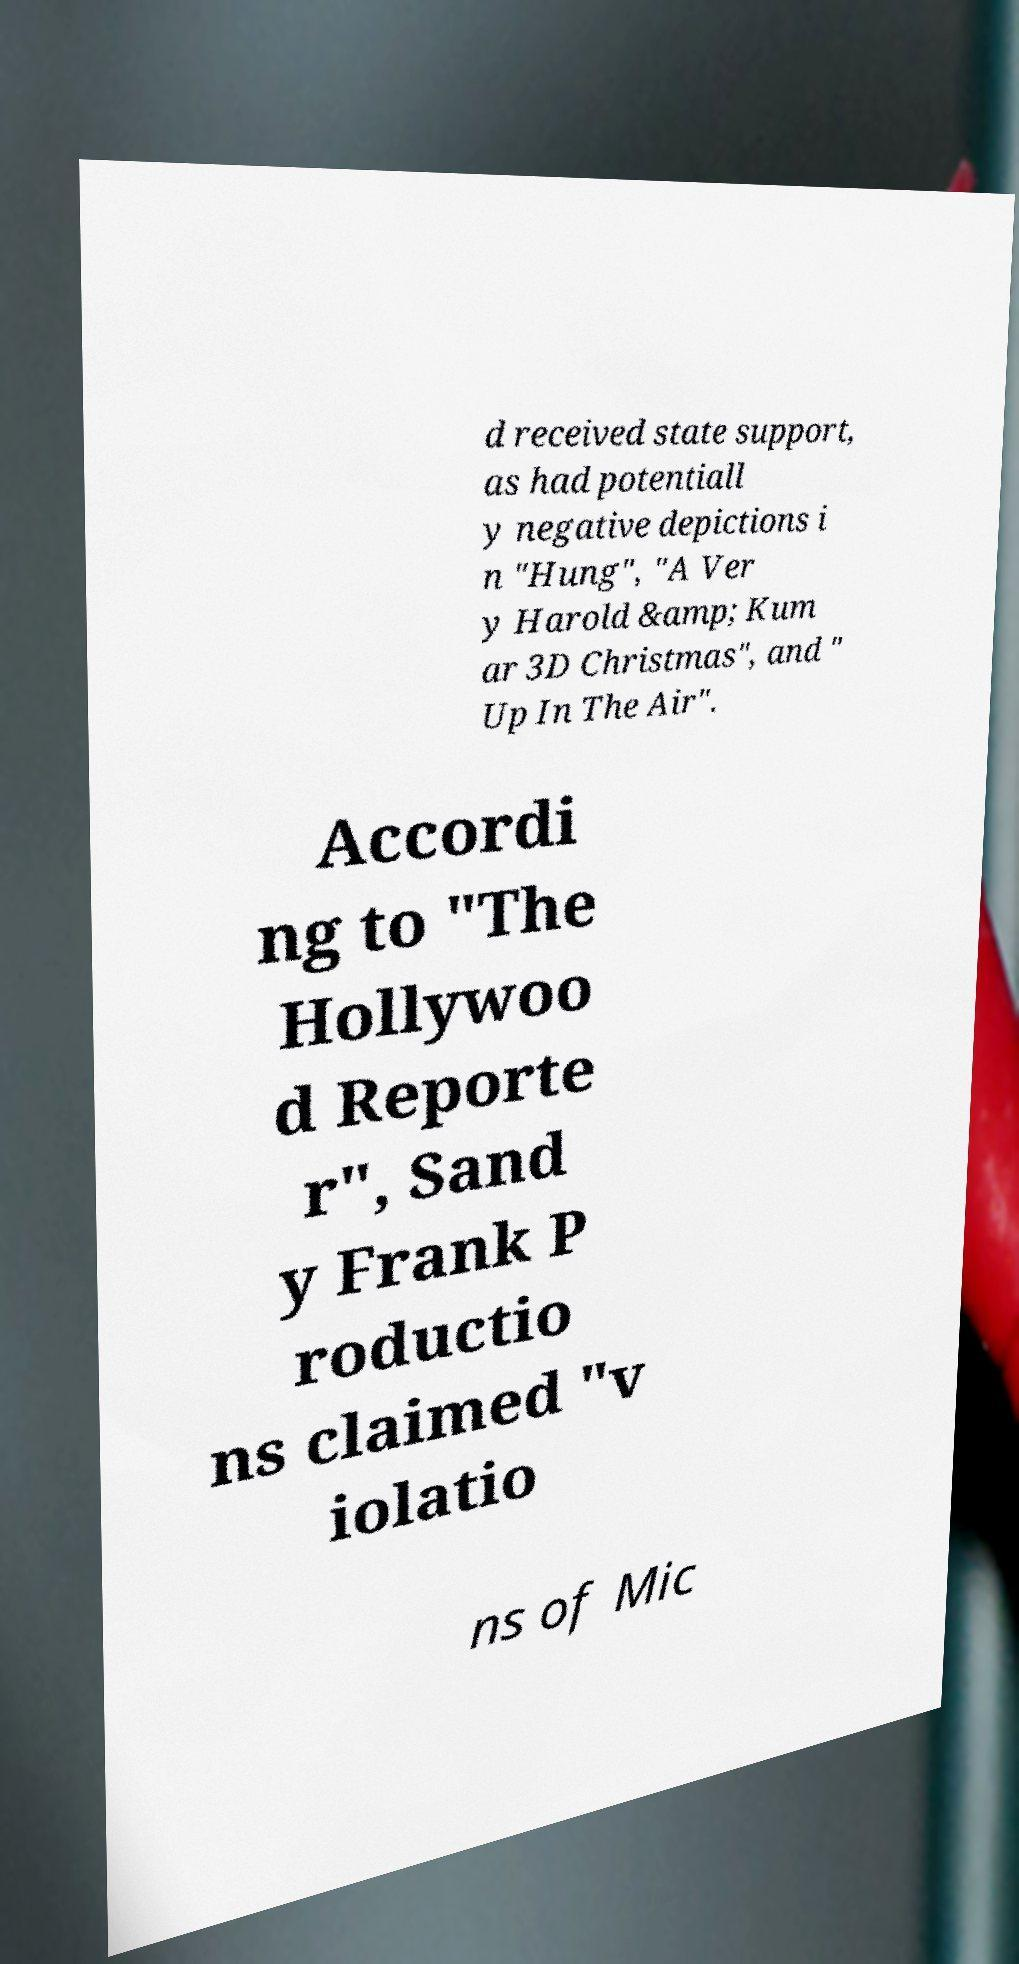Could you extract and type out the text from this image? d received state support, as had potentiall y negative depictions i n "Hung", "A Ver y Harold &amp; Kum ar 3D Christmas", and " Up In The Air". Accordi ng to "The Hollywoo d Reporte r", Sand y Frank P roductio ns claimed "v iolatio ns of Mic 